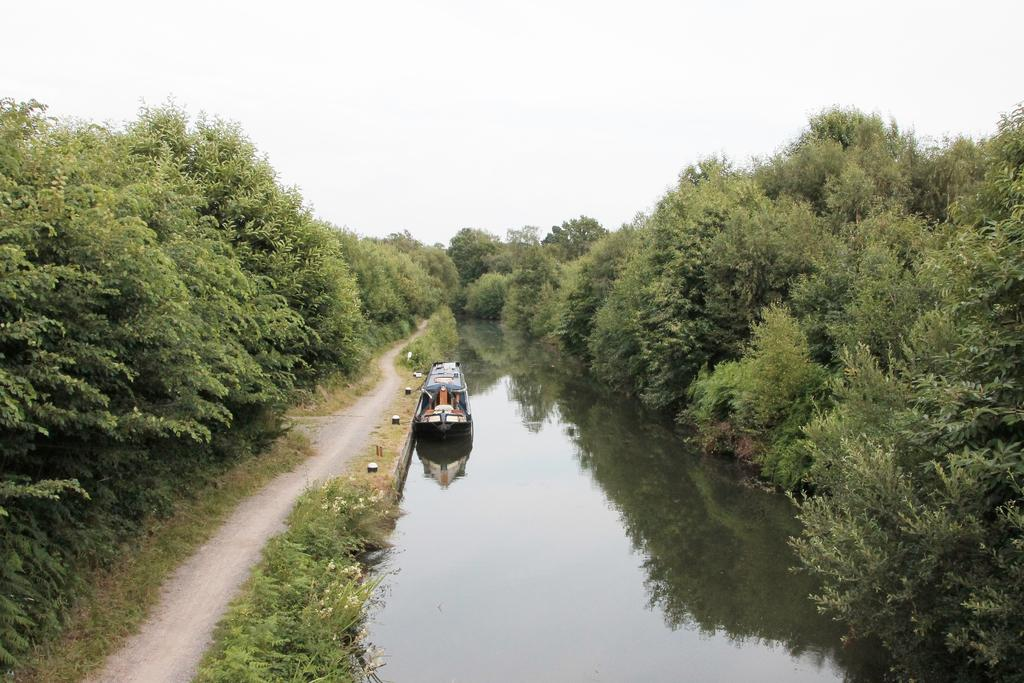What type of vegetation can be seen in the image? There are trees in the image. What natural element is also visible in the image? There is water visible in the image. What object is present in the water? There is a boat in the image. What type of ground cover is present in the image? There is grass in the image. What part of the natural environment is visible in the image? The sky is visible in the image. Can you see a worm crawling on the grass in the image? There is no worm visible in the image; it only features trees, water, a boat, grass, and the sky. What type of pleasure can be seen being experienced by the owl in the image? There is no owl present in the image. 